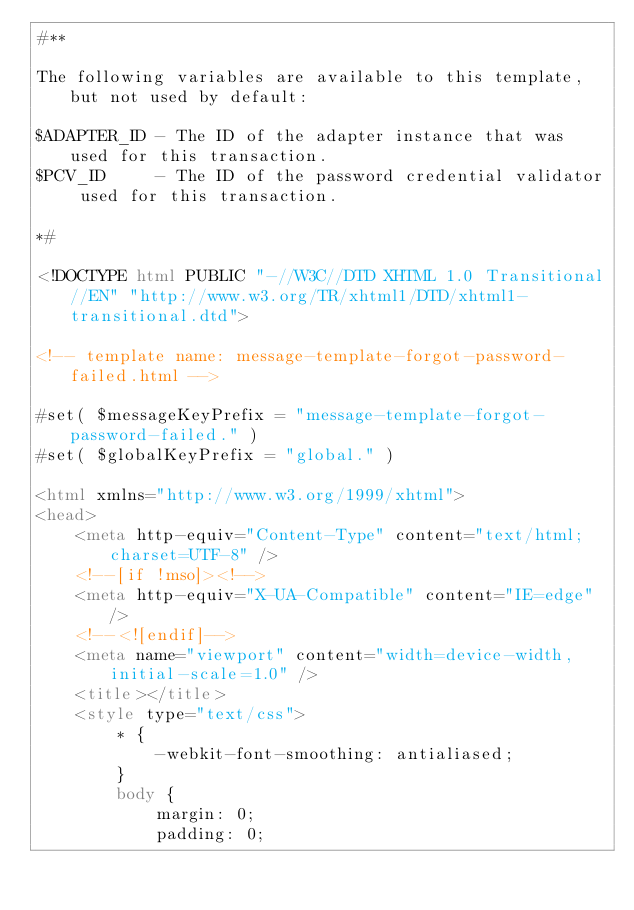Convert code to text. <code><loc_0><loc_0><loc_500><loc_500><_HTML_>#**

The following variables are available to this template, but not used by default:

$ADAPTER_ID - The ID of the adapter instance that was used for this transaction.
$PCV_ID     - The ID of the password credential validator used for this transaction.

*#

<!DOCTYPE html PUBLIC "-//W3C//DTD XHTML 1.0 Transitional//EN" "http://www.w3.org/TR/xhtml1/DTD/xhtml1-transitional.dtd">

<!-- template name: message-template-forgot-password-failed.html -->

#set( $messageKeyPrefix = "message-template-forgot-password-failed." )
#set( $globalKeyPrefix = "global." )

<html xmlns="http://www.w3.org/1999/xhtml">
<head>
    <meta http-equiv="Content-Type" content="text/html; charset=UTF-8" />
    <!--[if !mso]><!-->
    <meta http-equiv="X-UA-Compatible" content="IE=edge" />
    <!--<![endif]-->
    <meta name="viewport" content="width=device-width, initial-scale=1.0" />
    <title></title>
    <style type="text/css">
        * {
            -webkit-font-smoothing: antialiased;
        }
        body {
            margin: 0;
            padding: 0;</code> 